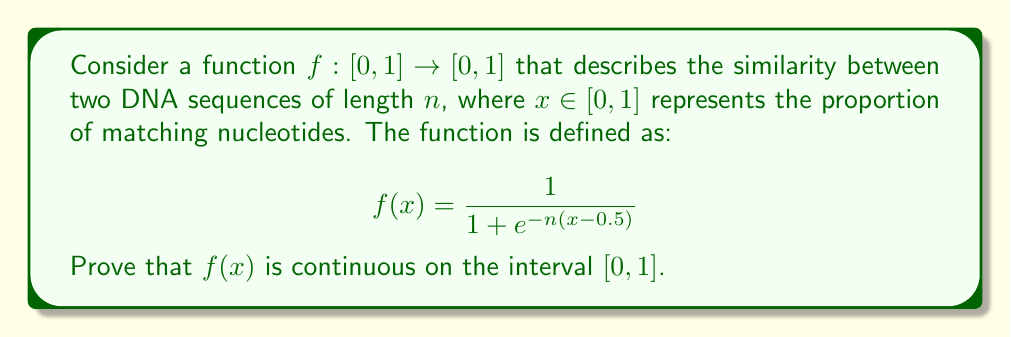Provide a solution to this math problem. To prove that $f(x)$ is continuous on the interval $[0,1]$, we need to show that it is continuous at every point in this interval. We can do this by demonstrating that $f(x)$ is a composition of continuous functions.

1) First, let's consider the inner function $g(x) = -n(x-0.5)$
   This is a linear function, which is continuous for all real numbers.

2) Next, we have the exponential function $h(y) = e^y$
   The exponential function is continuous for all real numbers.

3) Then, we have the function $k(z) = 1 + z$
   Addition of a constant is a continuous operation.

4) Finally, we have the reciprocal function $m(w) = \frac{1}{w}$
   This function is continuous for all $w \neq 0$.

Our function $f(x)$ is a composition of these functions:
$f(x) = m(k(h(g(x))))$

To show that $f(x)$ is continuous on $[0,1]$, we need to ensure that:
a) Each of these component functions is continuous on its relevant domain.
b) The composition doesn't lead to any points of discontinuity.

For a):
- $g(x)$ is continuous on $[0,1]$
- $h(y)$ is continuous for all real $y$
- $k(z)$ is continuous for all real $z$
- $m(w)$ is continuous for all $w \neq 0$

For b):
We need to check if $1 + e^{-n(x-0.5)}$ is ever zero for $x \in [0,1]$:

$$1 + e^{-n(x-0.5)} = 0$$
$$e^{-n(x-0.5)} = -1$$

This equation has no solution because $e^y > 0$ for all real $y$. Therefore, the denominator is never zero for $x \in [0,1]$.

Since all component functions are continuous on their relevant domains, and the composition doesn't introduce any points of discontinuity, we can conclude that $f(x)$ is continuous on $[0,1]$.
Answer: The function $f(x) = \frac{1}{1 + e^{-n(x-0.5)}}$ is continuous on the interval $[0,1]$ as it is a composition of continuous functions with no points of discontinuity in this interval. 